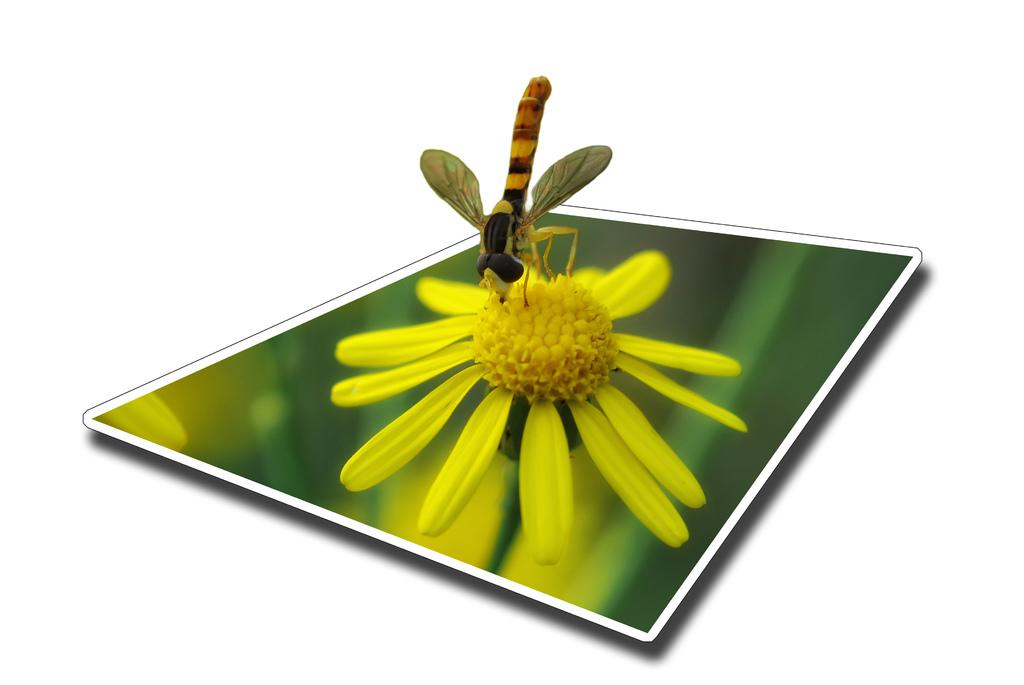What is the main object in the image? There is a board in the image. What is on the board? There is a flower on the board. Is there anything else on the flower? Yes, there is a fly on the flower. How many pickles are on the board in the image? There are no pickles present in the image; it features a board with a flower and a fly. What type of feather is on the flower in the image? There is no feather present on the flower in the image; it only has a fly. 